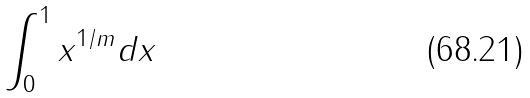Convert formula to latex. <formula><loc_0><loc_0><loc_500><loc_500>\int _ { 0 } ^ { 1 } x ^ { 1 / m } d x</formula> 